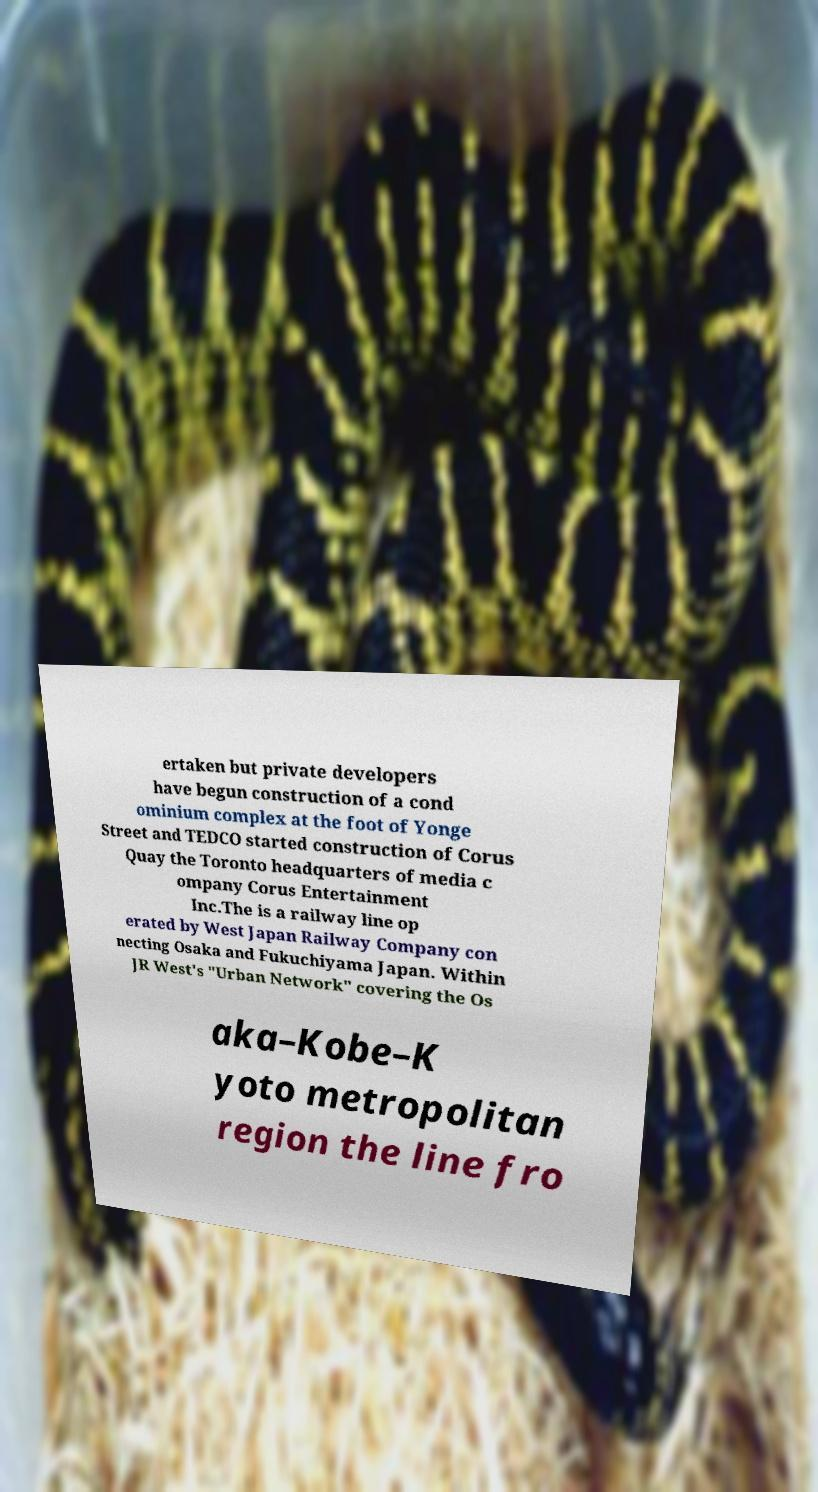There's text embedded in this image that I need extracted. Can you transcribe it verbatim? ertaken but private developers have begun construction of a cond ominium complex at the foot of Yonge Street and TEDCO started construction of Corus Quay the Toronto headquarters of media c ompany Corus Entertainment Inc.The is a railway line op erated by West Japan Railway Company con necting Osaka and Fukuchiyama Japan. Within JR West's "Urban Network" covering the Os aka–Kobe–K yoto metropolitan region the line fro 